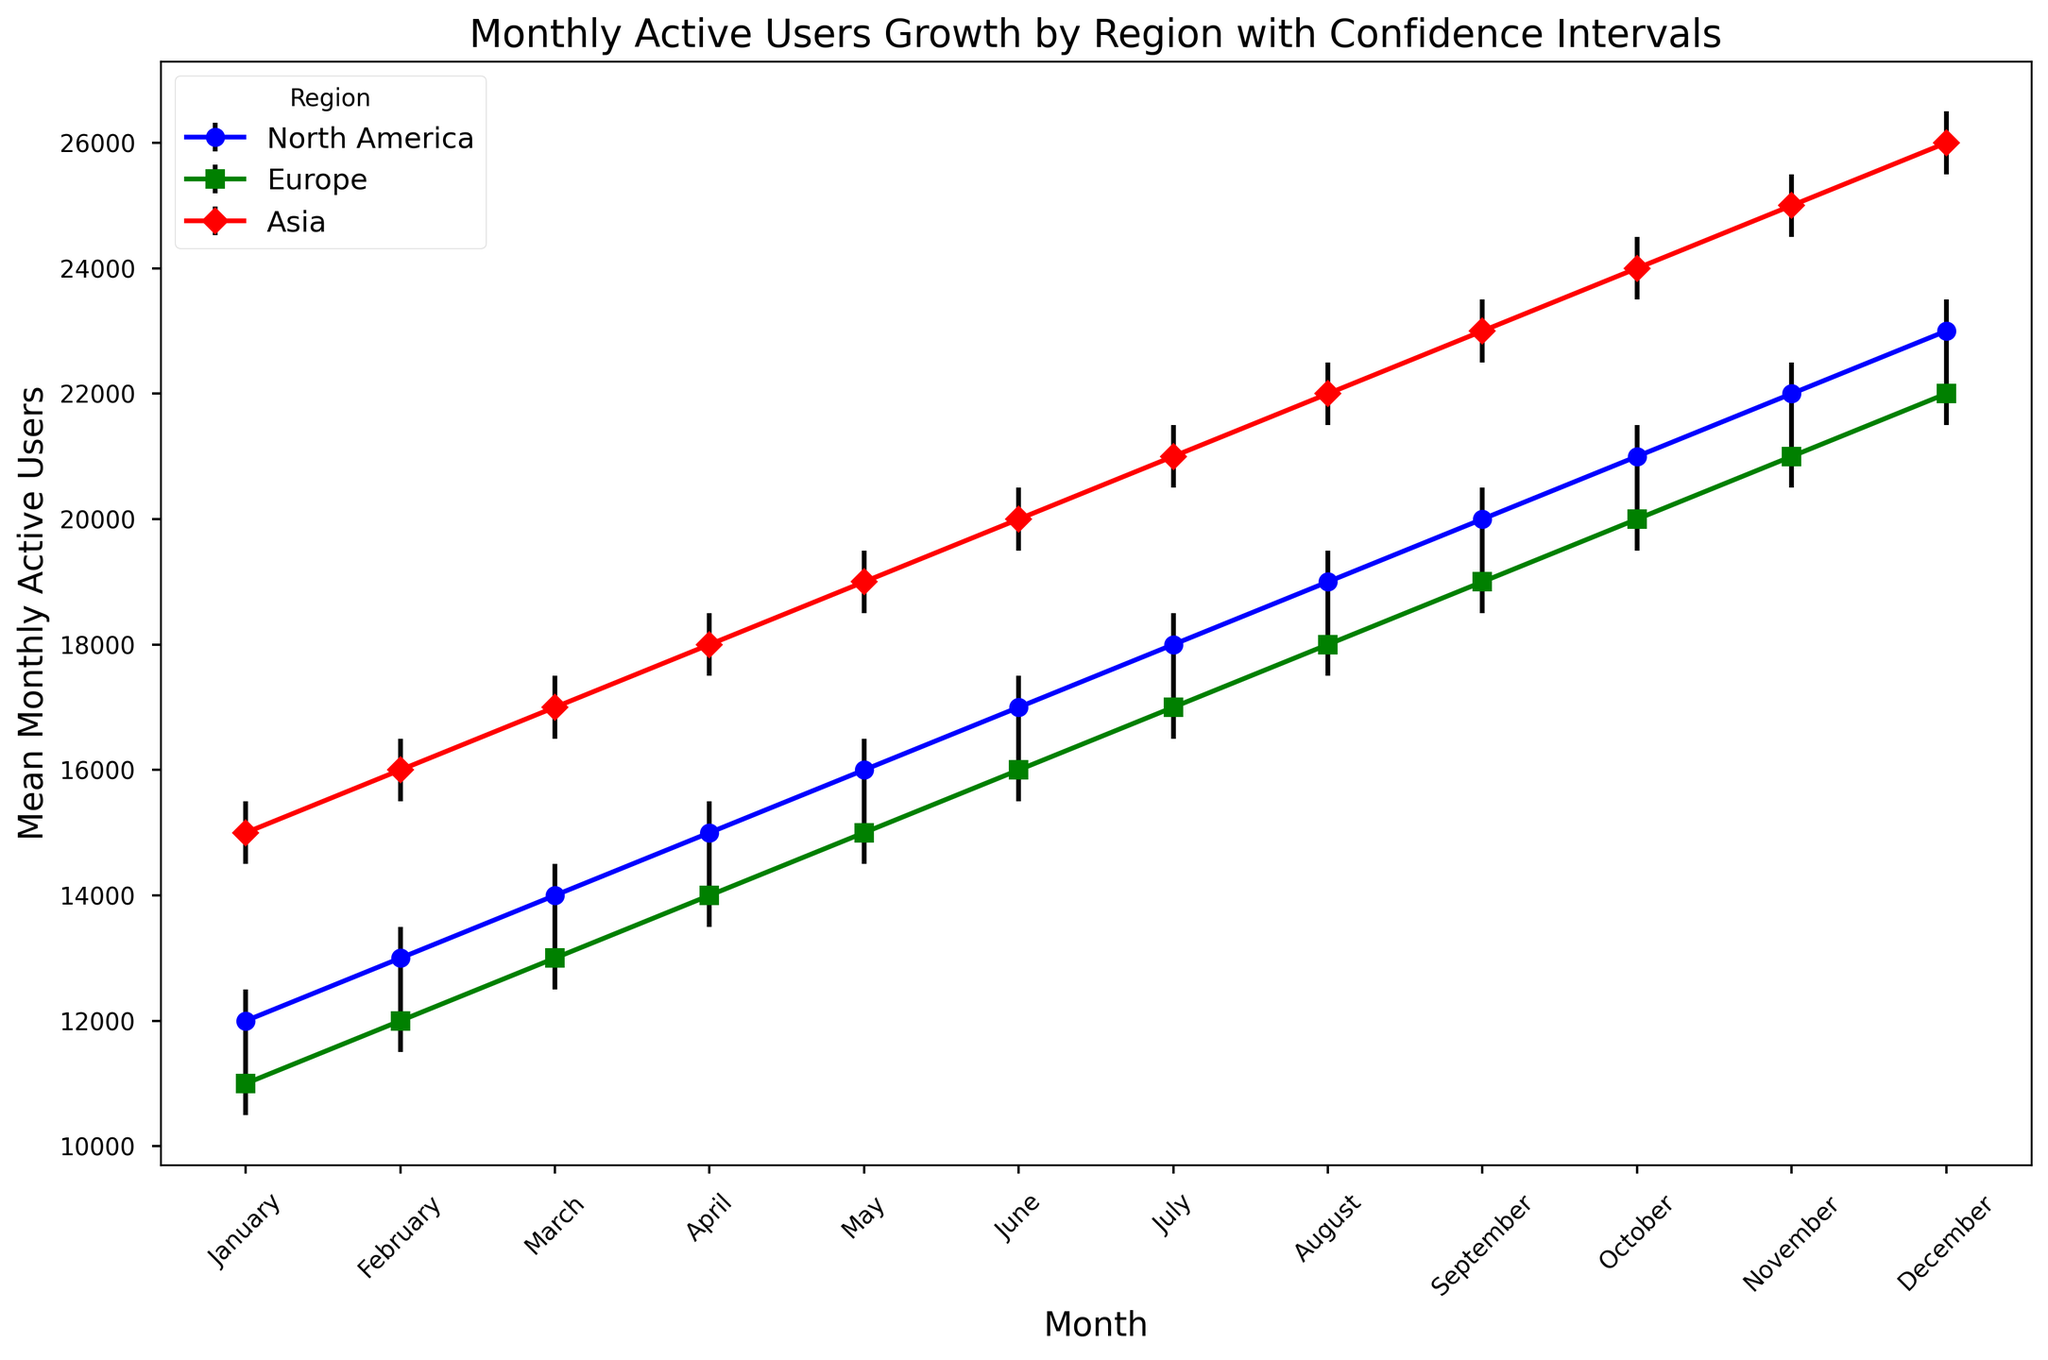What month did North America have the highest mean Monthly Active Users (MAUs)? By examining the plot, you can see that December is when North America reached its highest mean MAUs, marked at 23,000.
Answer: December Which region showed the greatest increase in mean MAUs from January to December? To find this, calculate the difference in mean MAUs between December and January for each region. North America increased from 12,000 to 23,000 (11,000 increase), Europe from 11,000 to 22,000 (11,000 increase), and Asia from 15,000 to 26,000 (11,000 increase). Since all regions showed the same increase, none is greater than the other.
Answer: All regions showed the same increase Which two months had the smallest difference in mean MAUs for Europe? Focus on Europe's line in the plot and examine the vertical positioning of points. The smallest difference is between consecutive months, and here it appears between each subsequent pair. Any two consecutive months will suffice, such as January to February (1,000 MAU difference).
Answer: January and February On which month did Asia surpass 25,000 mean MAUs for the first time? By observing the plotted line for Asia, you see the first point above 25,000 is in November, with a marked mean MAU at 25,000.
Answer: November What is the difference in mean MAUs between Europe and Asia in June? Subtract Europe’s mean MAUs in June (16,000) from Asia’s mean MAUs in June (20,000) to get the difference. 20,000 - 16,000 = 4,000.
Answer: 4,000 In which month do the confidence intervals for Europe and North America overlap? Identify months where the range of Europe’s upper and lower CI overlaps with North America’s. Both regions overlap from May onward due to proximity and consistency in error margins.
Answer: May onward Which region consistently shows the highest mean MAUs throughout the year? Visually, the region with the highest points across the year is Asia; the plot shows it above North America and Europe each month.
Answer: Asia 